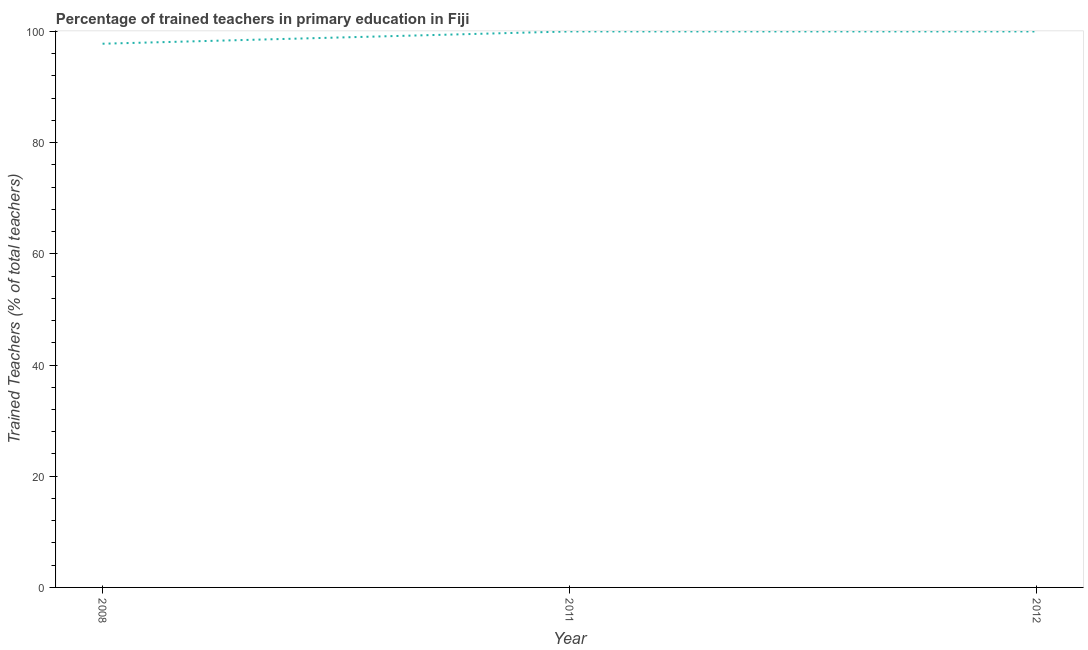Across all years, what is the maximum percentage of trained teachers?
Ensure brevity in your answer.  100. Across all years, what is the minimum percentage of trained teachers?
Your response must be concise. 97.79. What is the sum of the percentage of trained teachers?
Make the answer very short. 297.79. What is the difference between the percentage of trained teachers in 2011 and 2012?
Your answer should be very brief. 0. What is the average percentage of trained teachers per year?
Offer a terse response. 99.26. Do a majority of the years between 2012 and 2008 (inclusive) have percentage of trained teachers greater than 56 %?
Your answer should be compact. No. What is the ratio of the percentage of trained teachers in 2008 to that in 2012?
Your response must be concise. 0.98. What is the difference between the highest and the second highest percentage of trained teachers?
Offer a very short reply. 0. What is the difference between the highest and the lowest percentage of trained teachers?
Provide a succinct answer. 2.21. How many lines are there?
Your response must be concise. 1. How many years are there in the graph?
Your answer should be compact. 3. What is the difference between two consecutive major ticks on the Y-axis?
Provide a short and direct response. 20. Are the values on the major ticks of Y-axis written in scientific E-notation?
Provide a succinct answer. No. Does the graph contain any zero values?
Offer a terse response. No. What is the title of the graph?
Provide a succinct answer. Percentage of trained teachers in primary education in Fiji. What is the label or title of the X-axis?
Your response must be concise. Year. What is the label or title of the Y-axis?
Make the answer very short. Trained Teachers (% of total teachers). What is the Trained Teachers (% of total teachers) of 2008?
Your answer should be very brief. 97.79. What is the Trained Teachers (% of total teachers) in 2011?
Make the answer very short. 100. What is the Trained Teachers (% of total teachers) in 2012?
Offer a very short reply. 100. What is the difference between the Trained Teachers (% of total teachers) in 2008 and 2011?
Ensure brevity in your answer.  -2.21. What is the difference between the Trained Teachers (% of total teachers) in 2008 and 2012?
Keep it short and to the point. -2.21. What is the difference between the Trained Teachers (% of total teachers) in 2011 and 2012?
Give a very brief answer. 0. What is the ratio of the Trained Teachers (% of total teachers) in 2008 to that in 2011?
Provide a succinct answer. 0.98. What is the ratio of the Trained Teachers (% of total teachers) in 2011 to that in 2012?
Give a very brief answer. 1. 